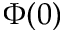Convert formula to latex. <formula><loc_0><loc_0><loc_500><loc_500>\Phi ( 0 )</formula> 